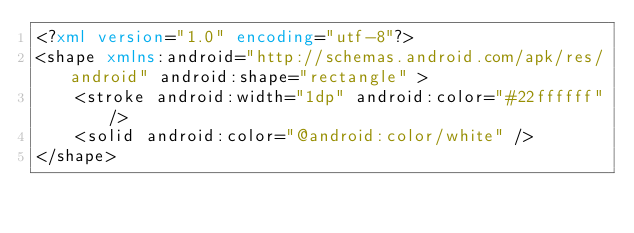<code> <loc_0><loc_0><loc_500><loc_500><_XML_><?xml version="1.0" encoding="utf-8"?>
<shape xmlns:android="http://schemas.android.com/apk/res/android" android:shape="rectangle" >
    <stroke android:width="1dp" android:color="#22ffffff"/>
    <solid android:color="@android:color/white" />
</shape></code> 